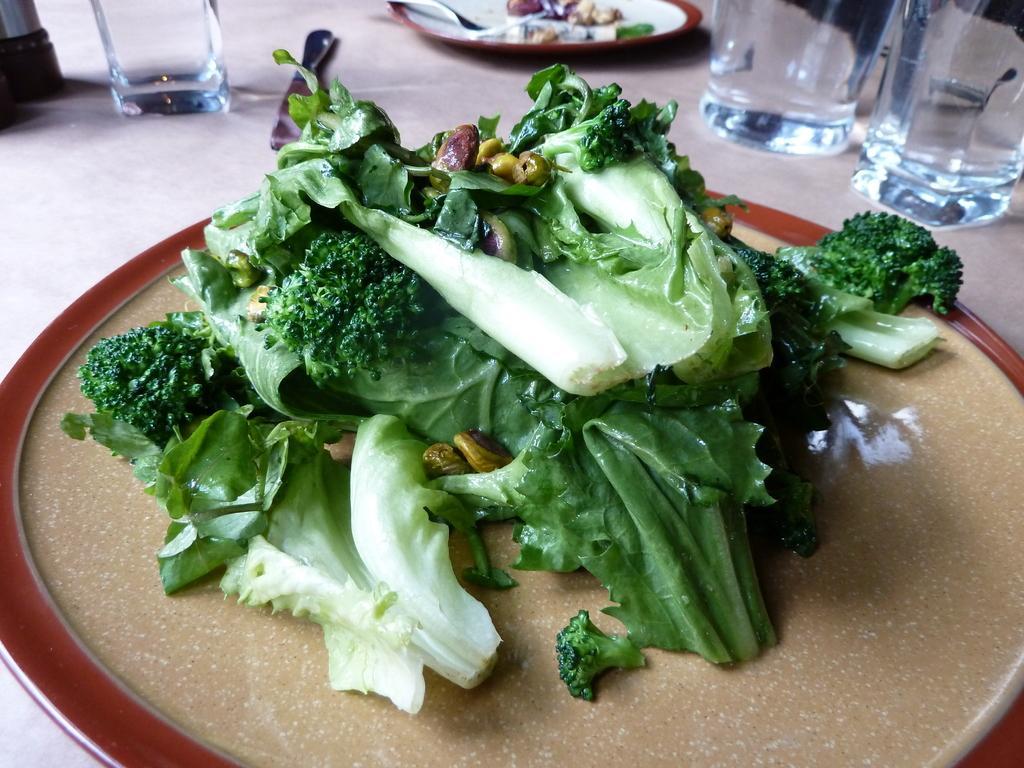How would you summarize this image in a sentence or two? In this image I can see few plates, few glasses, a knife and here I can see green vegetables. 